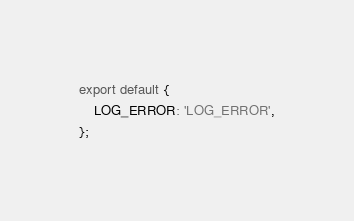Convert code to text. <code><loc_0><loc_0><loc_500><loc_500><_TypeScript_>export default {
    LOG_ERROR: 'LOG_ERROR',
};
</code> 